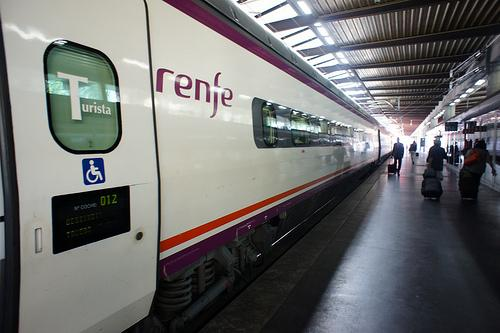What is written on the side of the train? Renfe is written on the side of the train. List three features noticeable on the exterior of the train. Windows on the train, a handicap sign, and a red stripe. Count the number of people visible in the image and describe their actions briefly. There are 5 people: one walking near the train, two standing near the train, and two pulling rolling luggage. Describe the door of the train and its notable features for potential passengers. The train door has a window, a handicap sign, a handle, and possibly an exit door on the side. What are the people near the train doing, and how many bags are they carrying? Two people are pulling rolling luggage, and there are three bags visible. Identify the type of train in the image based on its color. A white and purple train. What type of sign is found on the train door? There is a handicap sign on the train door. Estimate the number of windows on the side of the train. There are at least 4 windows on the side of the train. Analyze the sentiment portrayed in the image of the train station. The sentiment appears to be neutral, as people go about their daily routines at the train platform. Provide a short description of the platform and the train's surroundings. There is a train platform with people walking, a person pulling a suitcase, a ceiling, and wires above the train. 